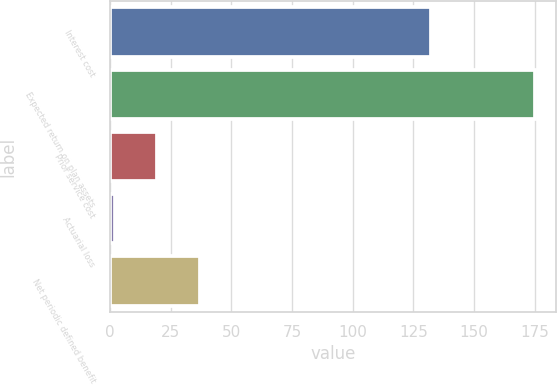<chart> <loc_0><loc_0><loc_500><loc_500><bar_chart><fcel>Interest cost<fcel>Expected return on plan assets<fcel>Prior service cost<fcel>Actuarial loss<fcel>Net periodic defined benefit<nl><fcel>132<fcel>175<fcel>19.3<fcel>2<fcel>37<nl></chart> 